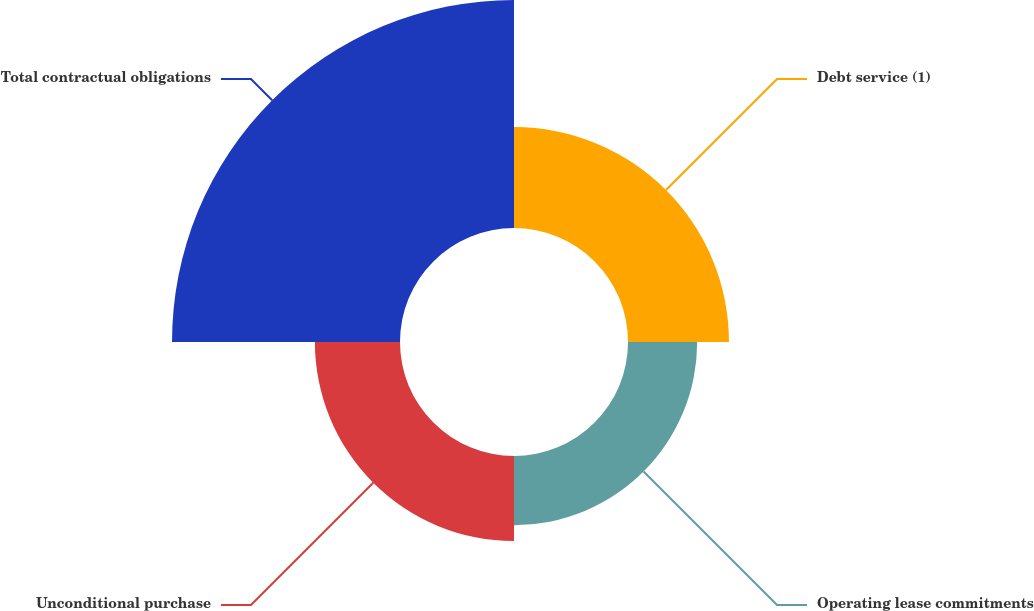<chart> <loc_0><loc_0><loc_500><loc_500><pie_chart><fcel>Debt service (1)<fcel>Operating lease commitments<fcel>Unconditional purchase<fcel>Total contractual obligations<nl><fcel>20.89%<fcel>14.32%<fcel>17.61%<fcel>47.18%<nl></chart> 